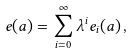Convert formula to latex. <formula><loc_0><loc_0><loc_500><loc_500>e ( a ) = \sum _ { i = 0 } ^ { \infty } \lambda ^ { i } e _ { i } ( a ) \, ,</formula> 